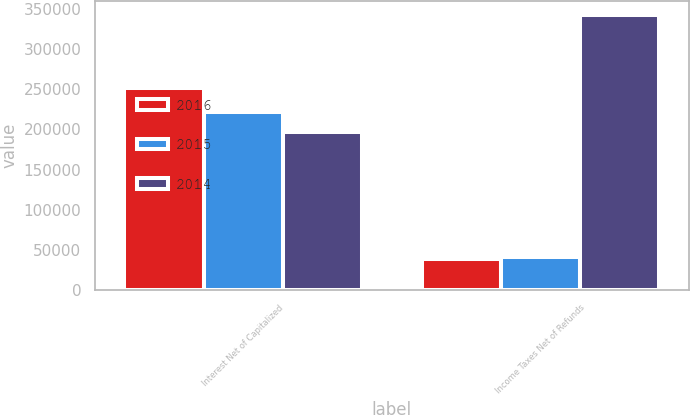Convert chart to OTSL. <chart><loc_0><loc_0><loc_500><loc_500><stacked_bar_chart><ecel><fcel>Interest Net of Capitalized<fcel>Income Taxes Net of Refunds<nl><fcel>2016<fcel>252030<fcel>39293<nl><fcel>2015<fcel>222088<fcel>41108<nl><fcel>2014<fcel>197383<fcel>342741<nl></chart> 